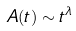<formula> <loc_0><loc_0><loc_500><loc_500>A ( t ) \sim t ^ { \lambda }</formula> 